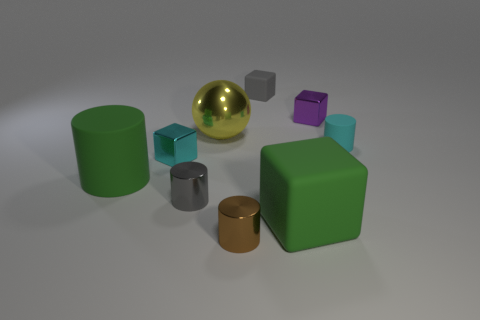Subtract all big blocks. How many blocks are left? 3 Subtract 2 cubes. How many cubes are left? 2 Subtract all cyan cubes. How many cubes are left? 3 Subtract all blue cylinders. Subtract all brown balls. How many cylinders are left? 4 Add 1 tiny cyan matte things. How many tiny cyan matte things exist? 2 Subtract 0 gray balls. How many objects are left? 9 Subtract all cylinders. How many objects are left? 5 Subtract all big shiny spheres. Subtract all purple metallic objects. How many objects are left? 7 Add 3 gray metal things. How many gray metal things are left? 4 